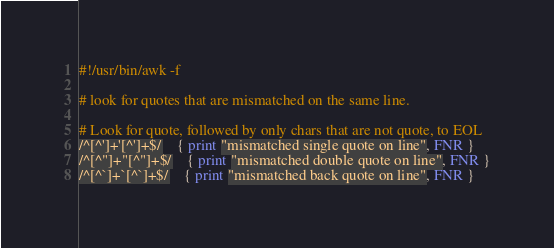Convert code to text. <code><loc_0><loc_0><loc_500><loc_500><_Awk_>#!/usr/bin/awk -f

# look for quotes that are mismatched on the same line.

# Look for quote, followed by only chars that are not quote, to EOL
/^[^']+'[^']+$/	{ print "mismatched single quote on line", FNR }
/^[^"]+"[^"]+$/	{ print "mismatched double quote on line", FNR }
/^[^`]+`[^`]+$/	{ print "mismatched back quote on line", FNR }
</code> 